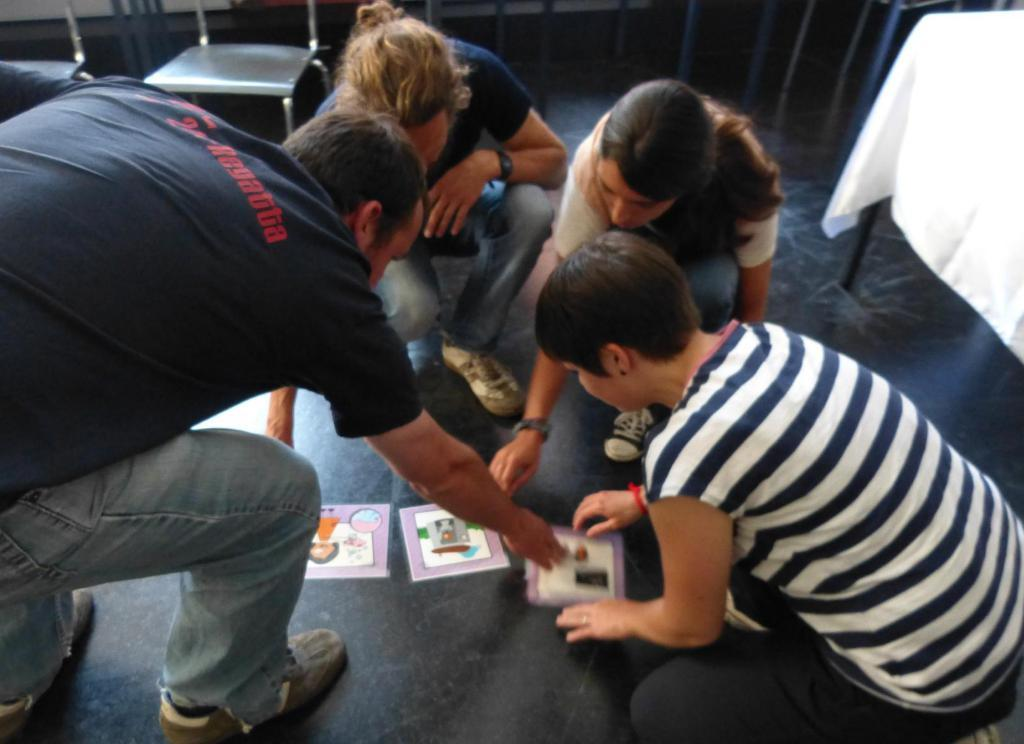How many people are present in the image? There are four persons in the image. What is on the floor in the image? There are papers on the floor. What type of furniture can be seen in the background? There are chairs and a table in the background. Can you tell me who won the fight in the image? There is no fight present in the image; it features four persons and papers on the floor. What type of drain is visible in the image? There is no drain present in the image. 